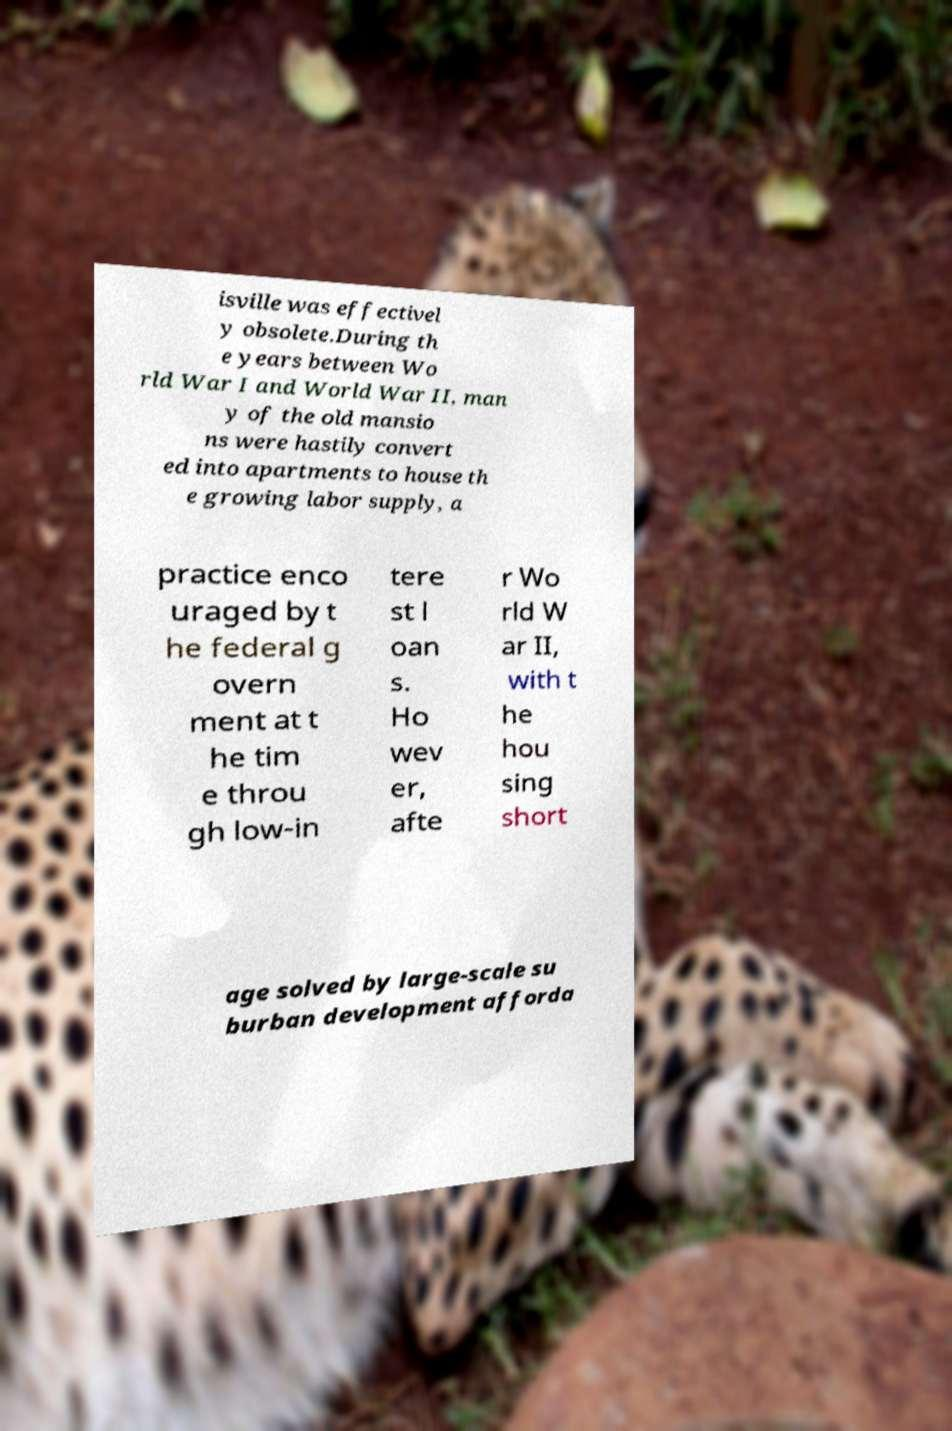Please read and relay the text visible in this image. What does it say? isville was effectivel y obsolete.During th e years between Wo rld War I and World War II, man y of the old mansio ns were hastily convert ed into apartments to house th e growing labor supply, a practice enco uraged by t he federal g overn ment at t he tim e throu gh low-in tere st l oan s. Ho wev er, afte r Wo rld W ar II, with t he hou sing short age solved by large-scale su burban development afforda 